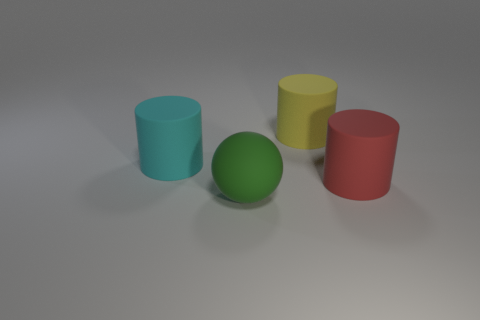What number of big matte objects are to the left of the big yellow matte thing and behind the red rubber cylinder?
Ensure brevity in your answer.  1. Is the size of the rubber thing on the left side of the green object the same as the rubber thing to the right of the yellow rubber object?
Your response must be concise. Yes. What number of objects are cylinders in front of the yellow rubber thing or purple shiny cubes?
Your answer should be very brief. 2. What is the cyan cylinder made of?
Give a very brief answer. Rubber. There is a yellow rubber object; does it have the same size as the rubber cylinder that is on the left side of the big green sphere?
Offer a terse response. Yes. What number of things are either large things that are in front of the yellow object or large things right of the green thing?
Your answer should be compact. 4. There is a big cylinder on the right side of the large yellow object; what color is it?
Your answer should be very brief. Red. Is there a big thing that is to the left of the big object right of the yellow cylinder?
Your answer should be compact. Yes. Are there fewer brown rubber cubes than large red objects?
Keep it short and to the point. Yes. How many objects are either large green balls or large cyan rubber things?
Make the answer very short. 2. 